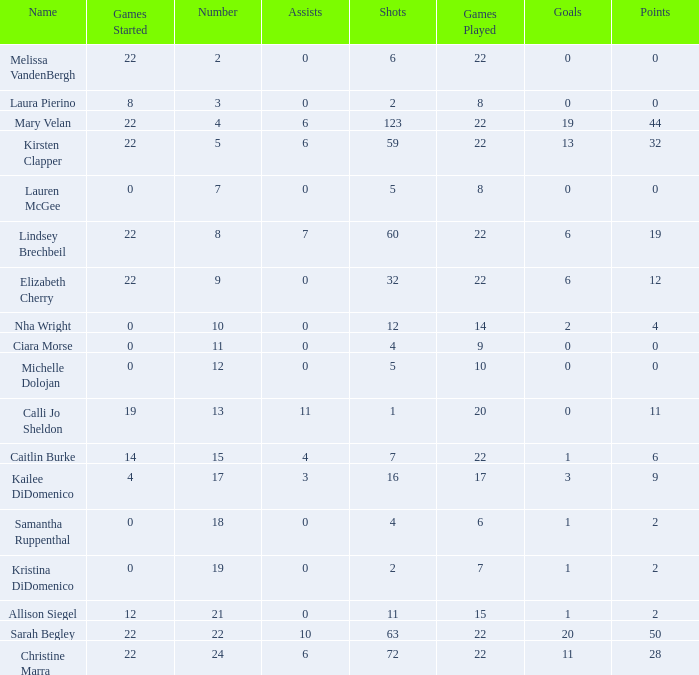How many numbers belong to the player with 10 assists?  1.0. 